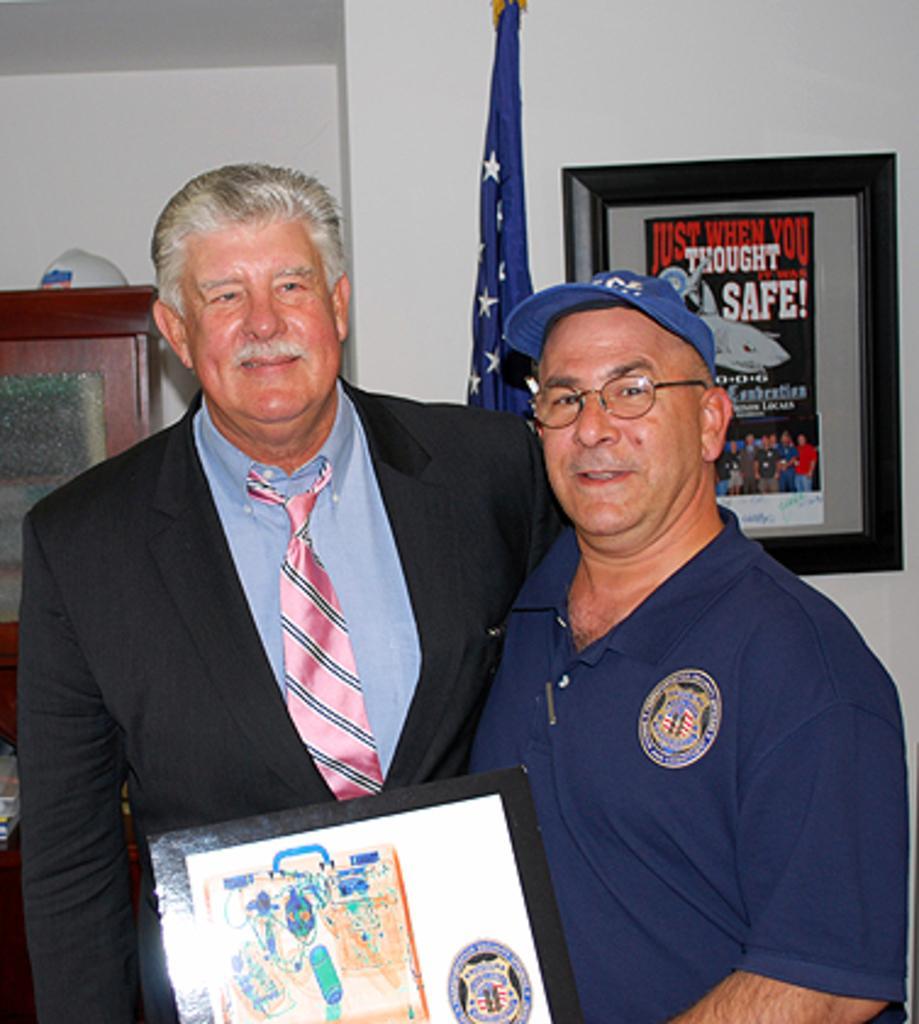Please provide a concise description of this image. In the center of the image, we can see people standing and one of them is wearing glasses and a cap and holding a frame and the other is wearing a coat and a tie. In the background, there is a flag and we can see a board placed on the wall and there is a cupboard and some other objects. 